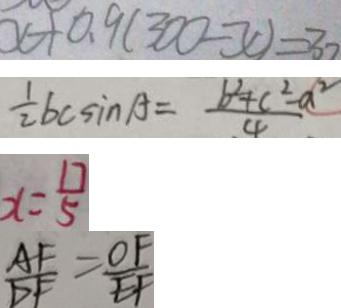<formula> <loc_0><loc_0><loc_500><loc_500>x + 0 . 9 ( 3 0 0 - x ) = 3 0 
 \frac { 1 } { 2 } b c \sin A = \frac { b ^ { 2 } + c ^ { 2 } - a ^ { 2 } } { 4 } 
 x = \frac { 1 7 } { 5 } 
 \frac { A F } { D F } = \frac { O F } { E F }</formula> 